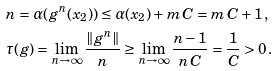Convert formula to latex. <formula><loc_0><loc_0><loc_500><loc_500>& n = \alpha ( g ^ { n } ( x _ { 2 } ) ) \leq \alpha ( x _ { 2 } ) + m \, C = m \, C + 1 \, , \\ & \tau ( g ) = \lim _ { n \rightarrow \infty } \frac { \| g ^ { n } \| } { n } \geq \lim _ { n \rightarrow \infty } \frac { n - 1 } { n \, C } = \frac { 1 } { C } > 0 \, .</formula> 